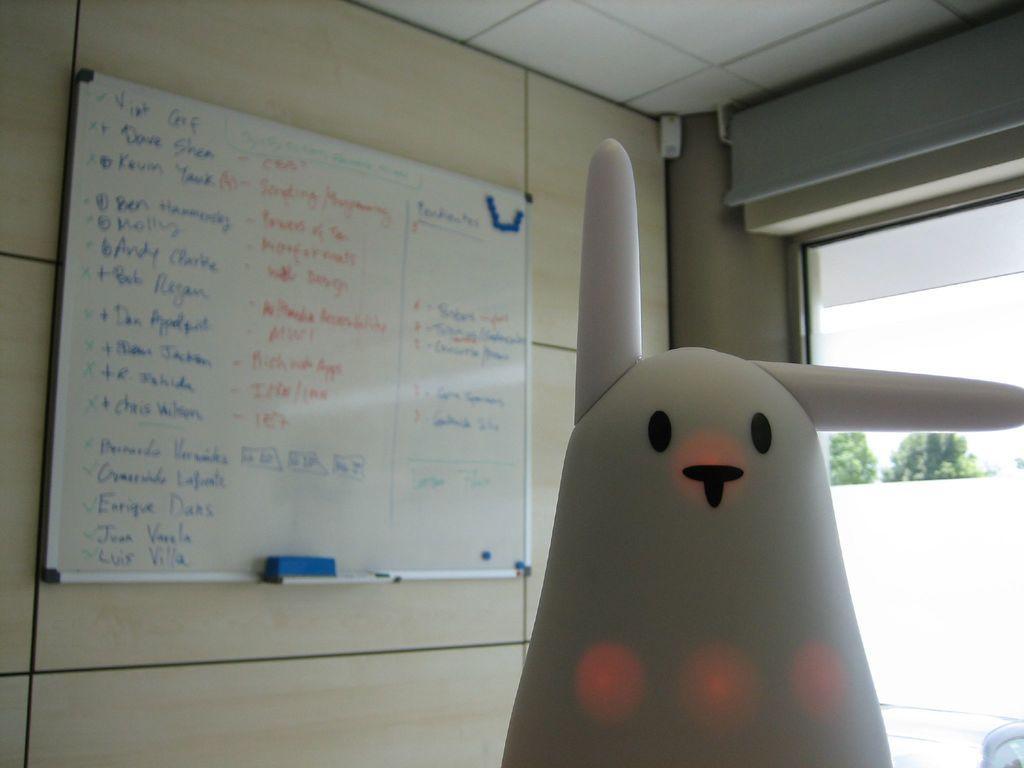In one or two sentences, can you explain what this image depicts? In this picture a toy and a board on which something written on it. On the right side I can see trees and window. On the board I can see a duster. 